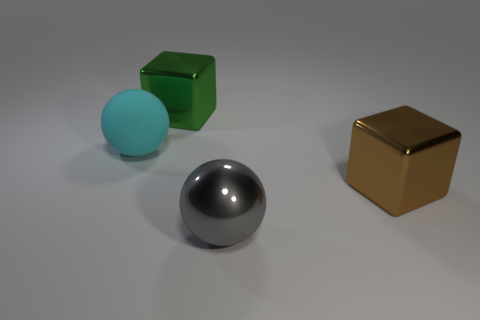Is there a large cyan sphere that has the same material as the big brown block?
Your response must be concise. No. What number of green objects are cubes or metal spheres?
Give a very brief answer. 1. Is there another big sphere that has the same color as the metal ball?
Offer a very short reply. No. There is a green cube that is made of the same material as the gray object; what is its size?
Provide a short and direct response. Large. How many cubes are green shiny objects or big brown things?
Offer a terse response. 2. Is the number of big metallic objects greater than the number of big objects?
Your response must be concise. No. What number of green blocks have the same size as the gray thing?
Your response must be concise. 1. How many objects are big metal blocks right of the green thing or large spheres?
Provide a short and direct response. 3. Is the number of large red shiny spheres less than the number of green metallic objects?
Your response must be concise. Yes. The green object that is made of the same material as the brown thing is what shape?
Keep it short and to the point. Cube. 